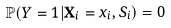Convert formula to latex. <formula><loc_0><loc_0><loc_500><loc_500>\mathbb { P } ( Y = 1 | \mathbf X _ { i } = x _ { i } , S _ { i } ) = 0</formula> 